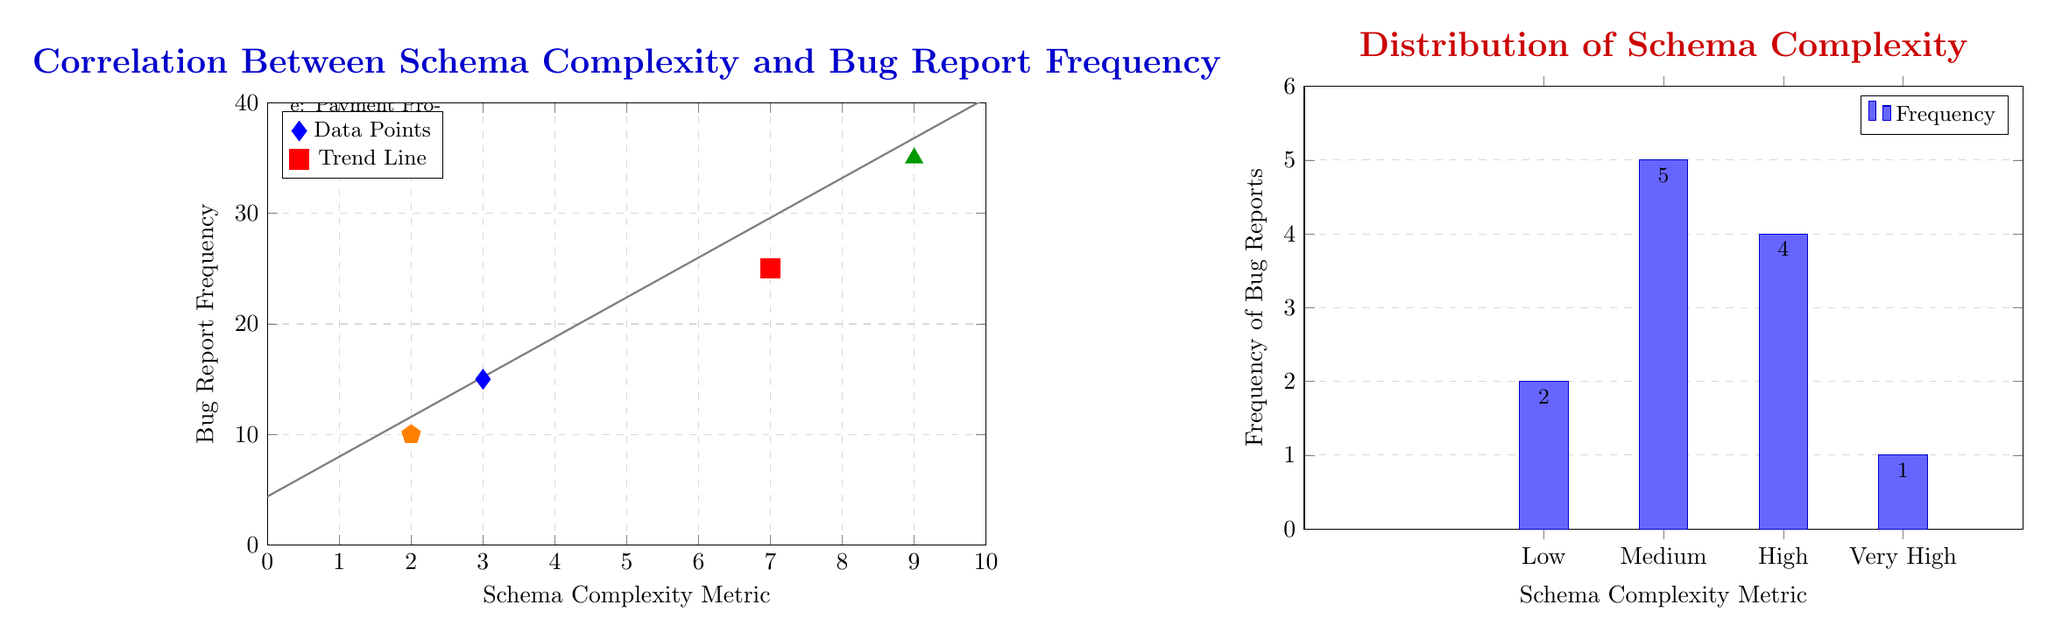What's the highest bug report frequency in the scatter plot? The scatter plot shows the y-axis ranging from 0 to 40. By observing the points plotted, the highest y-value is 35, represented by the data point corresponding to order management.
Answer: 35 How many data points are represented in the scatter plot? Observing the scatter plot, there are five distinct points plotted, each representing a specific schema complexity and bug report frequency correlation.
Answer: 5 What is the schema complexity metric for user authentication? In the scatter plot, user authentication is represented by the label 'a', which corresponds to an x-value of 3, indicating its schema complexity metric.
Answer: 3 Which schema complexity metric has the highest frequency of bug reports? Referring to the histogram, the highest frequency of bug reports corresponds to the medium complexity metric (2), where the bug report frequency is 5.
Answer: Medium What is the trend line equation represented in the scatter plot? The trend line depicted suggests a positive correlation. The equation derived from the graph indicates the relationship as y = 3.6x + 4.4, which can be extracted from the graphical representation of the trend line.
Answer: y = 3.6x + 4.4 How does the frequency of bug reports change with increasing schema complexity? Observing the scatter plot, one can see a general increase in bug report frequency as schema complexity metric increases, indicating a positive correlation between the two.
Answer: Positive correlation What type of data visualization is the second diagram? The second diagram employs a bar chart, illustrating the distribution of bug report frequencies categorized by different schema complexity levels.
Answer: Bar chart How many bug reports were recorded for very high complexity? The histogram indicates that there is only 1 bug report recorded for the very high schema complexity category, as shown by the height of the corresponding bar.
Answer: 1 What is the frequency of bug reports for low schema complexity? From the histogram, the low schema complexity category shows a frequency of 2, as denoted by the bar's height for that category.
Answer: 2 